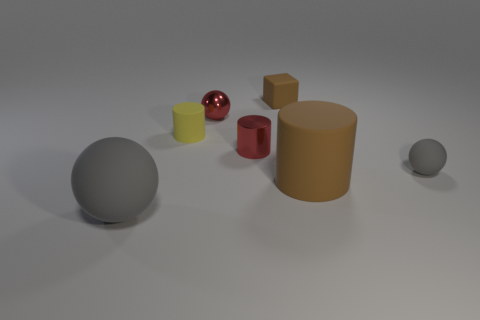Are there any other things that have the same shape as the tiny brown rubber thing?
Provide a short and direct response. No. How many things are red things or big matte cylinders?
Your answer should be very brief. 3. How many other objects are the same color as the large rubber cylinder?
Provide a succinct answer. 1. The gray matte object that is the same size as the yellow cylinder is what shape?
Offer a terse response. Sphere. The object left of the small yellow matte thing is what color?
Offer a very short reply. Gray. How many objects are yellow things that are behind the large sphere or rubber objects right of the red ball?
Your response must be concise. 4. Is the brown rubber cube the same size as the brown cylinder?
Provide a short and direct response. No. What number of cylinders are either large brown rubber things or yellow rubber things?
Offer a terse response. 2. How many gray rubber objects are both on the left side of the large brown cylinder and behind the big ball?
Keep it short and to the point. 0. There is a yellow rubber thing; is its size the same as the ball behind the small gray matte ball?
Ensure brevity in your answer.  Yes. 